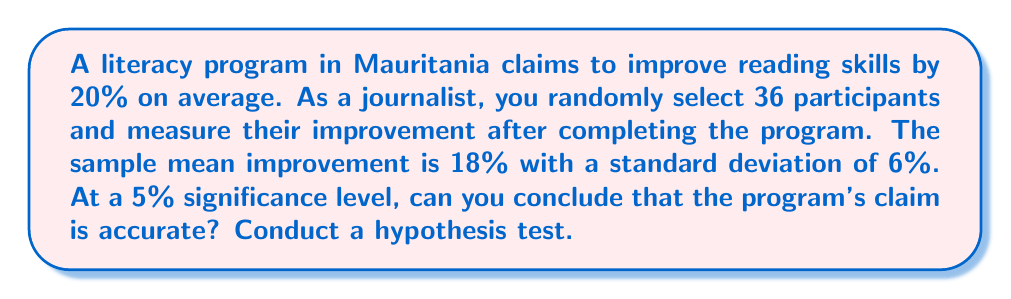Teach me how to tackle this problem. 1. Set up the hypotheses:
   $H_0: \mu = 20$ (null hypothesis: true mean improvement is 20%)
   $H_a: \mu \neq 20$ (alternative hypothesis: true mean improvement is not 20%)

2. Choose the significance level: $\alpha = 0.05$

3. Calculate the test statistic (z-score):
   $$z = \frac{\bar{x} - \mu_0}{s/\sqrt{n}}$$
   where $\bar{x}$ is the sample mean, $\mu_0$ is the hypothesized population mean,
   $s$ is the sample standard deviation, and $n$ is the sample size.

   $$z = \frac{18 - 20}{6/\sqrt{36}} = \frac{-2}{1} = -2$$

4. Find the critical values for a two-tailed test at $\alpha = 0.05$:
   $z_{\alpha/2} = \pm 1.96$

5. Compare the test statistic to the critical values:
   $-2 < -1.96$, so the test statistic falls in the rejection region.

6. Calculate the p-value:
   $p = 2 \times P(Z < -2) = 2 \times 0.0228 = 0.0456$

7. Compare the p-value to the significance level:
   $0.0456 < 0.05$, so we reject the null hypothesis.
Answer: Reject $H_0$; insufficient evidence to support the program's claim of 20% improvement. 